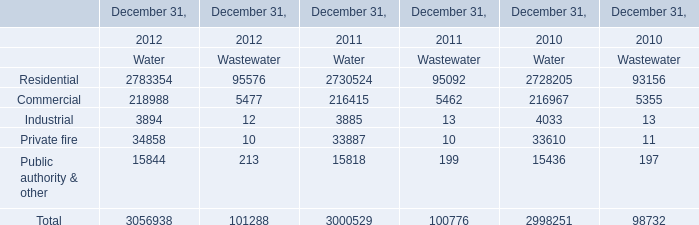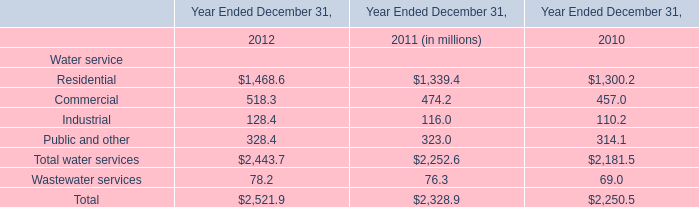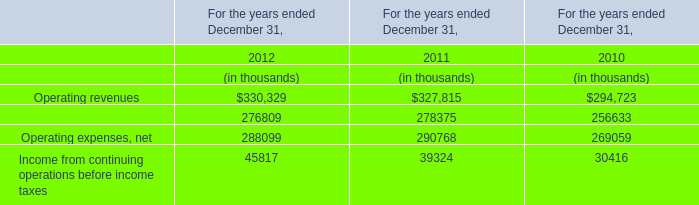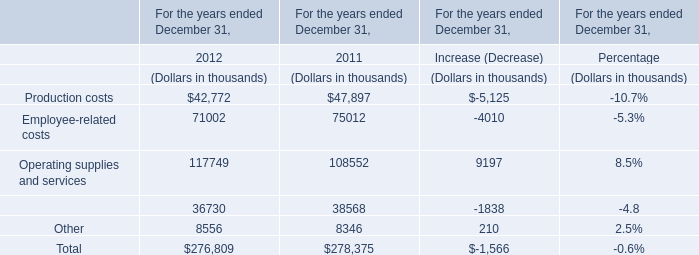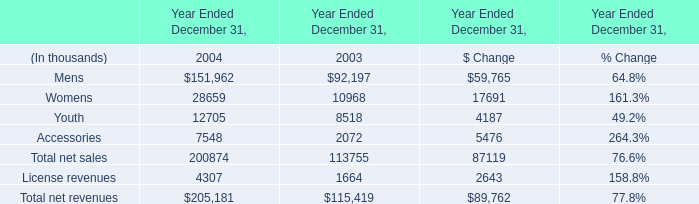What is the growing rate of Accessories in the year with the most Mens? 
Computations: ((7548 - 2072) / 7548)
Answer: 0.72549. 